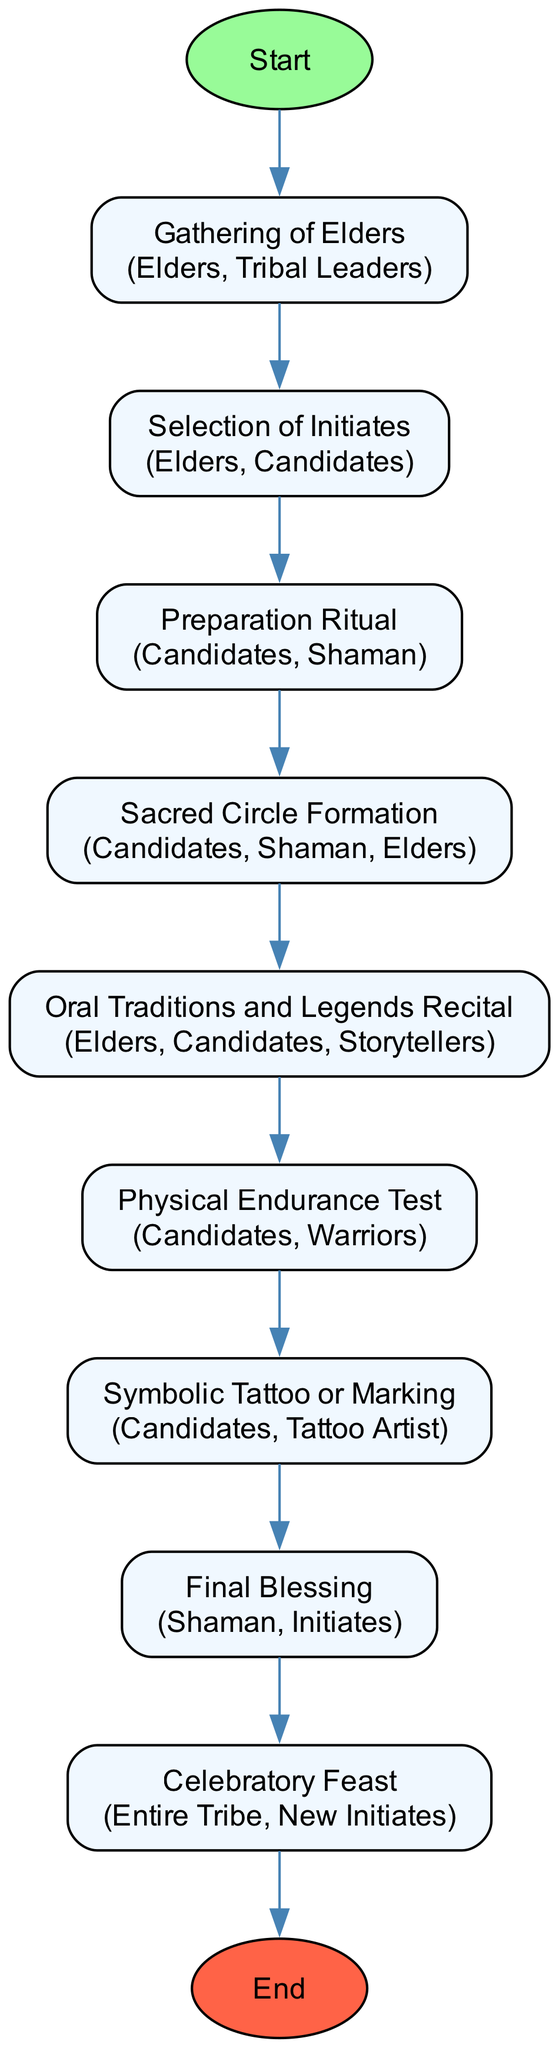What is the first activity in the initiation process? The first activity listed in the diagram is "Gathering of Elders," which is the starting point of the initiation process.
Answer: Gathering of Elders How many activities are there in total? The diagram outlines a total of nine activities that form part of the initiation process.
Answer: 9 Which activity involves physical challenges? The activity that involves physical challenges is "Physical Endurance Test," where candidates participate in a series of challenges to prove their strength and resilience.
Answer: Physical Endurance Test Who performs the final blessing? The "Final Blessing" is performed by the Shaman, as indicated in the description of that activity.
Answer: Shaman What do the candidates receive to signify their transition into adulthood? Candidates receive a "Symbolic Tattoo or Marking" signifying their transition into adulthood during the initiation process.
Answer: Symbolic Tattoo or Marking What is the last activity before the celebratory feast? The last activity before the celebratory feast is the "Final Blessing," which solidifies the initiate's new status within the tribe.
Answer: Final Blessing How many initiates are involved in the Sacred Circle Formation? The initiates involved in the "Sacred Circle Formation" activity include Candidates, Shaman, and Elders, totaling three groups of initiates.
Answer: 3 Which tribe members are involved in the "Celebratory Feast"? The "Celebratory Feast" involves the entire tribe and the new initiates, so both groups participate in this final activity.
Answer: Entire Tribe, New Initiates What is the primary purpose of the "Oral Traditions and Legends Recital"? The primary purpose of the "Oral Traditions and Legends Recital" is to recount tribal legends and taboos to the initiates during the initiation process.
Answer: Storytelling Session 